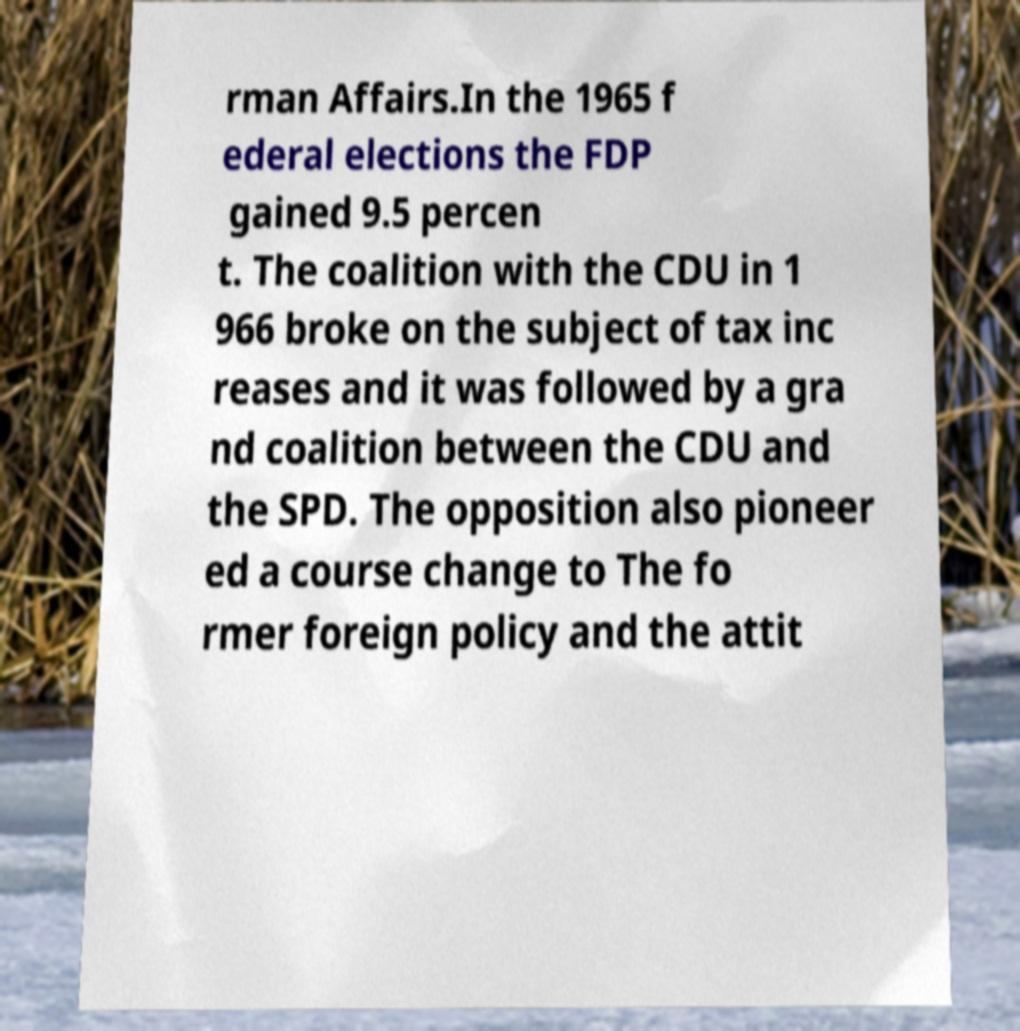Could you assist in decoding the text presented in this image and type it out clearly? rman Affairs.In the 1965 f ederal elections the FDP gained 9.5 percen t. The coalition with the CDU in 1 966 broke on the subject of tax inc reases and it was followed by a gra nd coalition between the CDU and the SPD. The opposition also pioneer ed a course change to The fo rmer foreign policy and the attit 